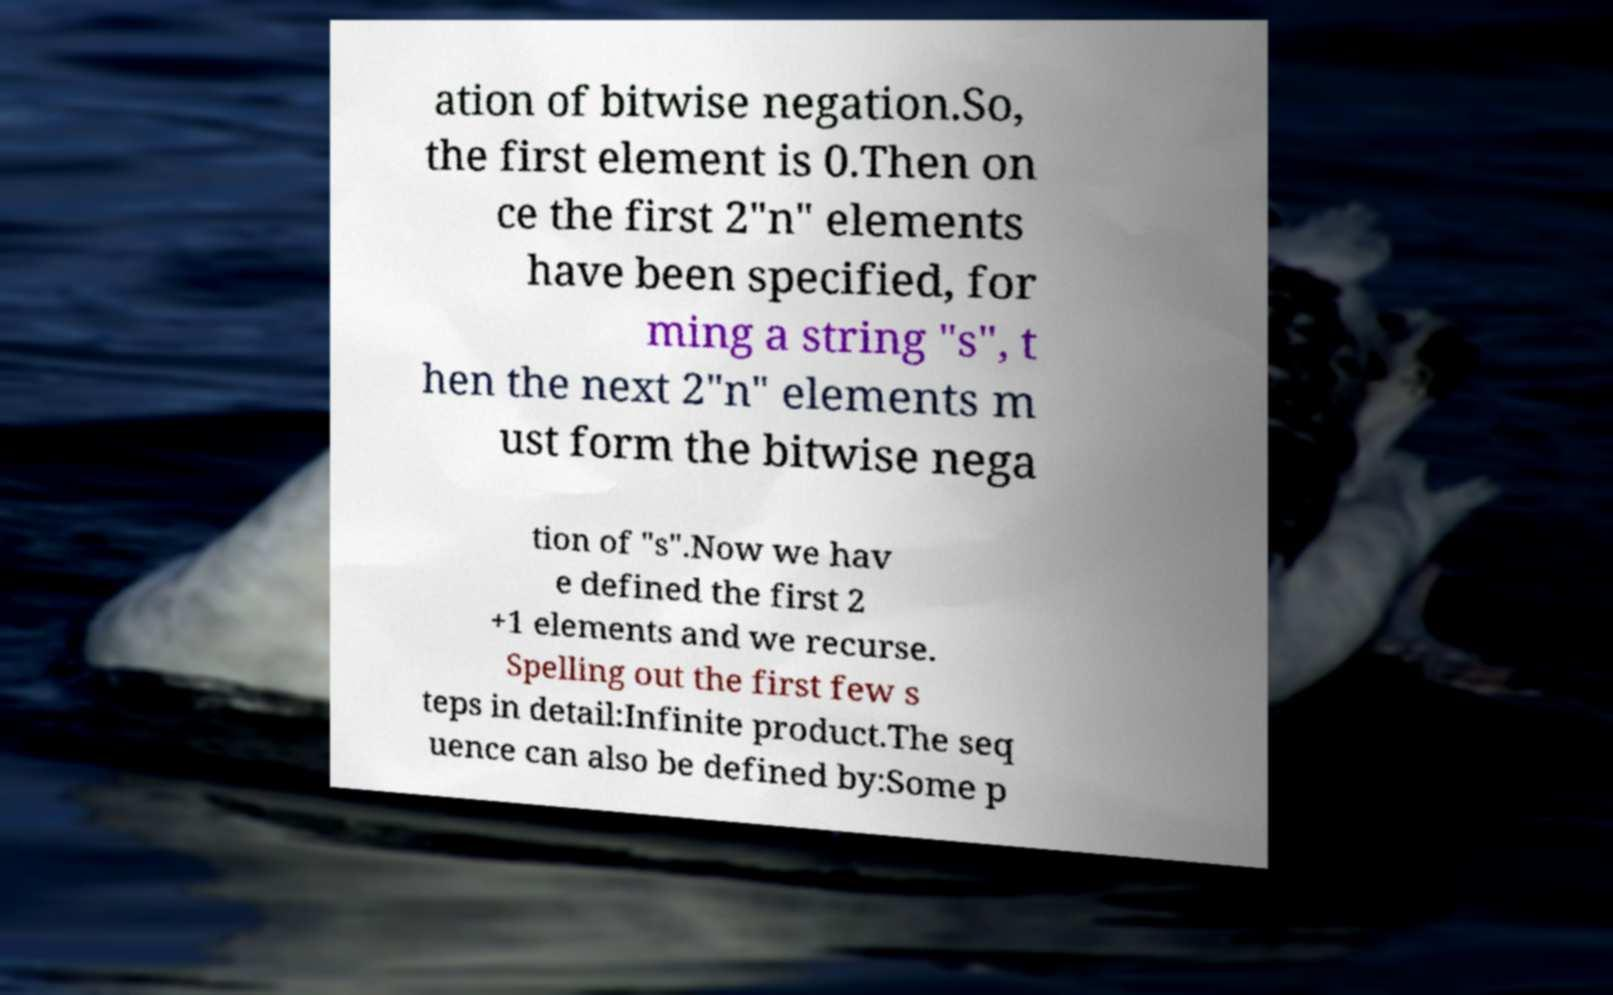Could you extract and type out the text from this image? ation of bitwise negation.So, the first element is 0.Then on ce the first 2"n" elements have been specified, for ming a string "s", t hen the next 2"n" elements m ust form the bitwise nega tion of "s".Now we hav e defined the first 2 +1 elements and we recurse. Spelling out the first few s teps in detail:Infinite product.The seq uence can also be defined by:Some p 